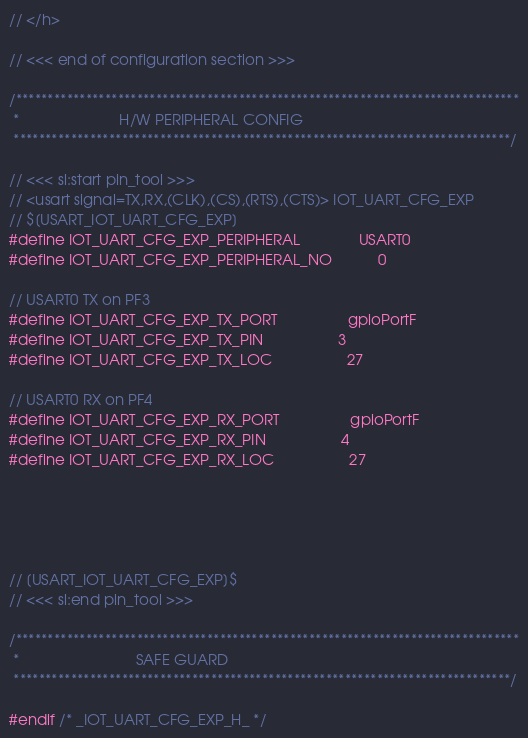Convert code to text. <code><loc_0><loc_0><loc_500><loc_500><_C_>// </h>

// <<< end of configuration section >>>

/*******************************************************************************
 *                        H/W PERIPHERAL CONFIG
 ******************************************************************************/

// <<< sl:start pin_tool >>>
// <usart signal=TX,RX,(CLK),(CS),(RTS),(CTS)> IOT_UART_CFG_EXP
// $[USART_IOT_UART_CFG_EXP]
#define IOT_UART_CFG_EXP_PERIPHERAL              USART0
#define IOT_UART_CFG_EXP_PERIPHERAL_NO           0

// USART0 TX on PF3
#define IOT_UART_CFG_EXP_TX_PORT                 gpioPortF
#define IOT_UART_CFG_EXP_TX_PIN                  3
#define IOT_UART_CFG_EXP_TX_LOC                  27

// USART0 RX on PF4
#define IOT_UART_CFG_EXP_RX_PORT                 gpioPortF
#define IOT_UART_CFG_EXP_RX_PIN                  4
#define IOT_UART_CFG_EXP_RX_LOC                  27





// [USART_IOT_UART_CFG_EXP]$
// <<< sl:end pin_tool >>>

/*******************************************************************************
 *                            SAFE GUARD
 ******************************************************************************/

#endif /* _IOT_UART_CFG_EXP_H_ */
</code> 